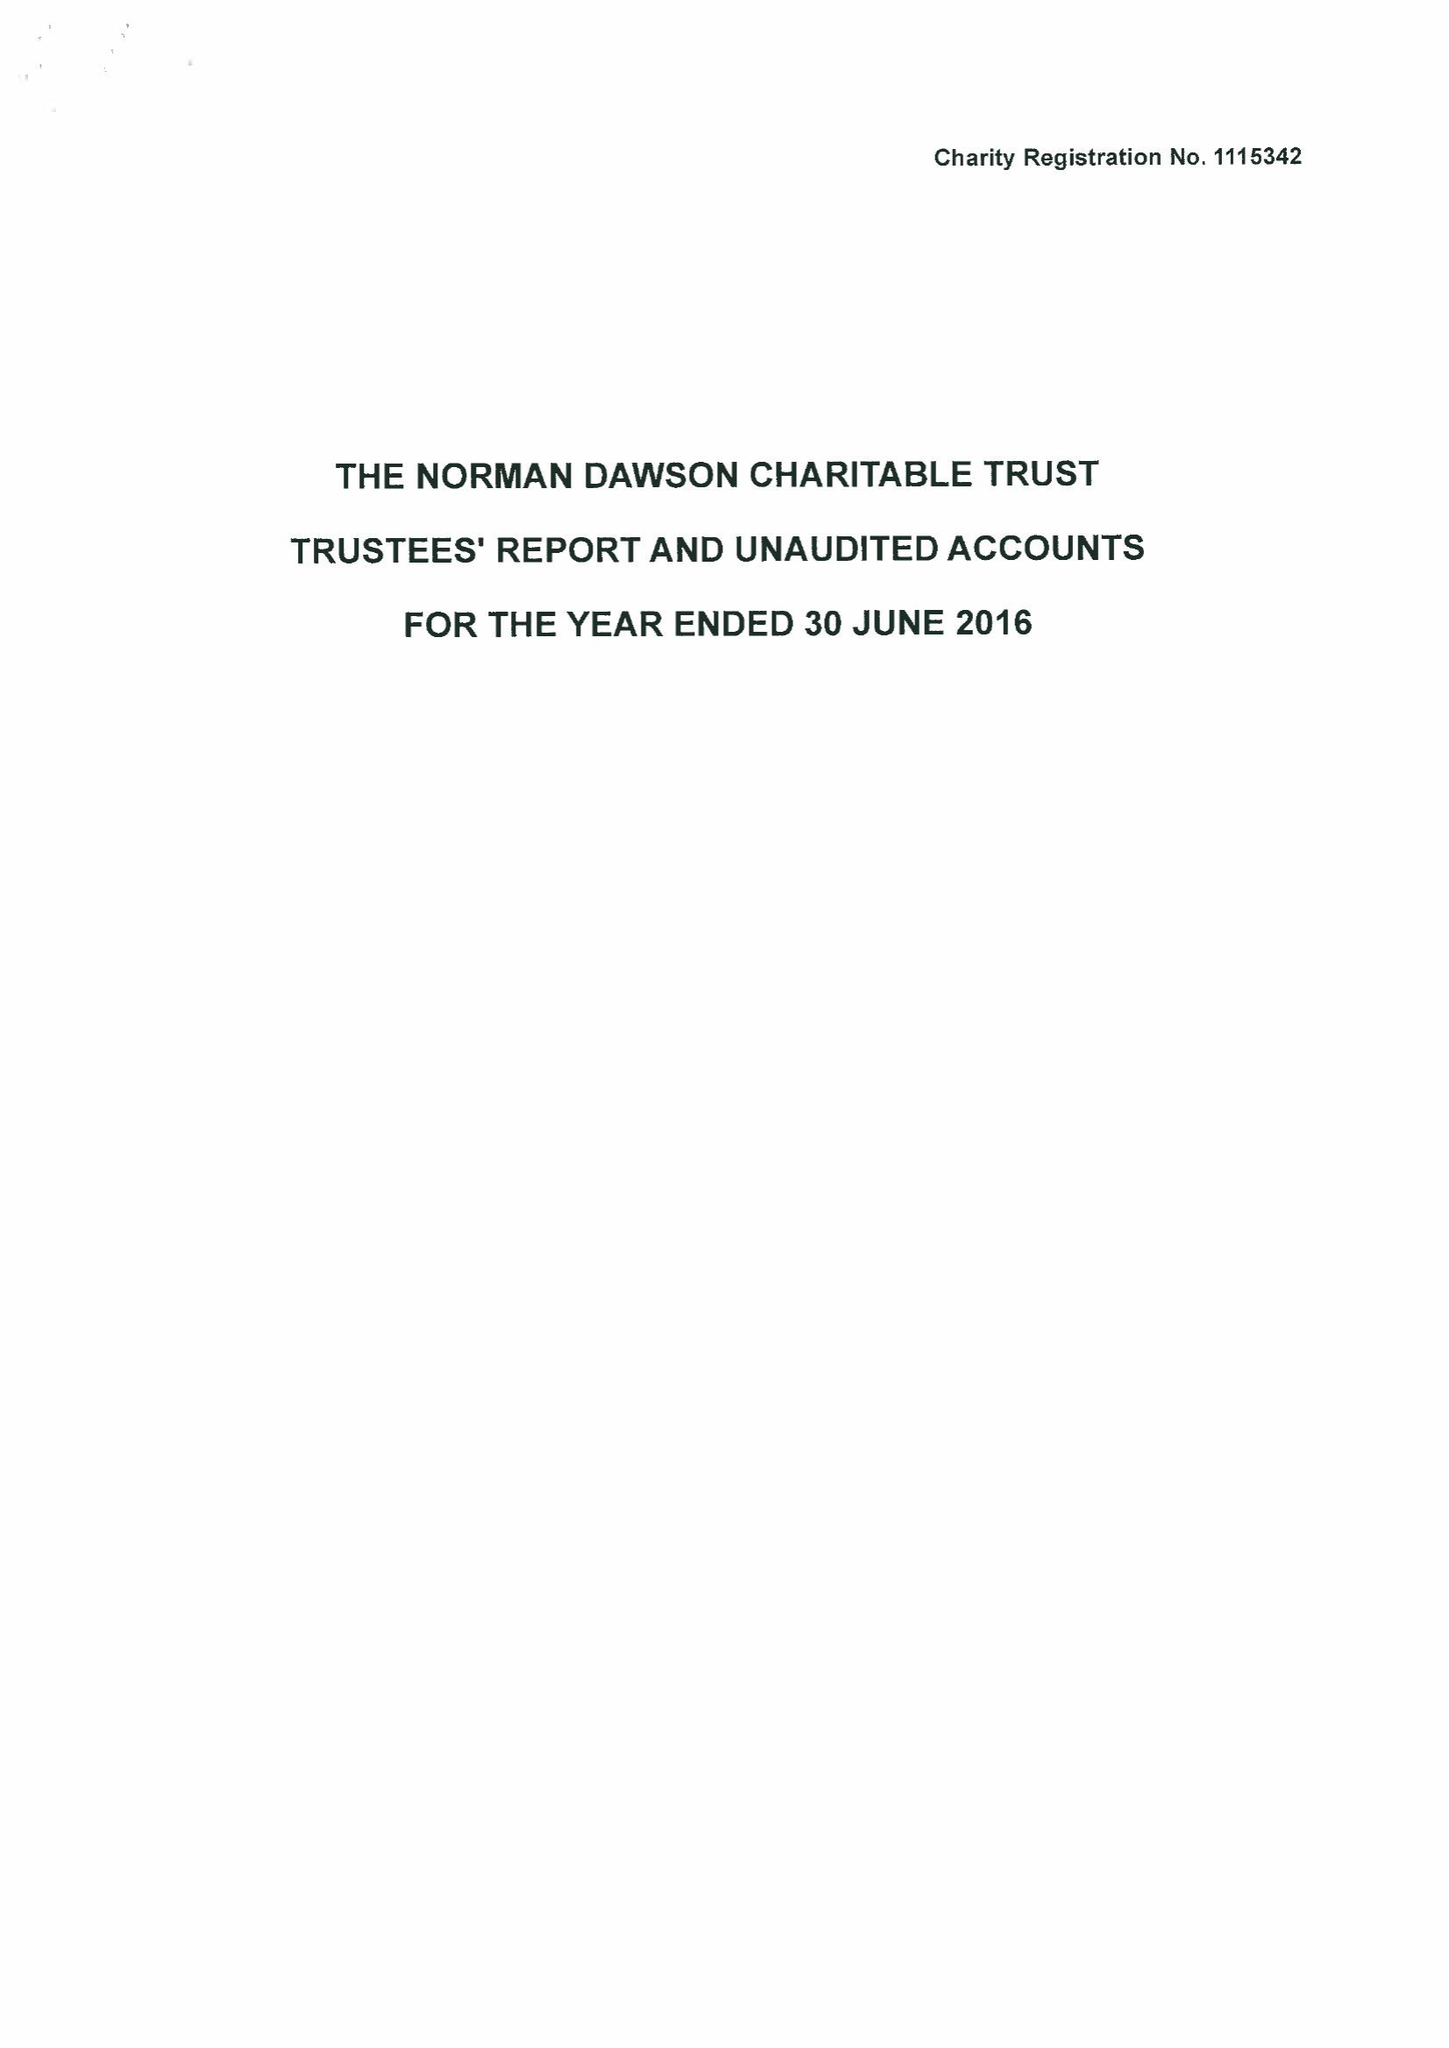What is the value for the charity_name?
Answer the question using a single word or phrase. The Norman Dawson Charitable Trust 